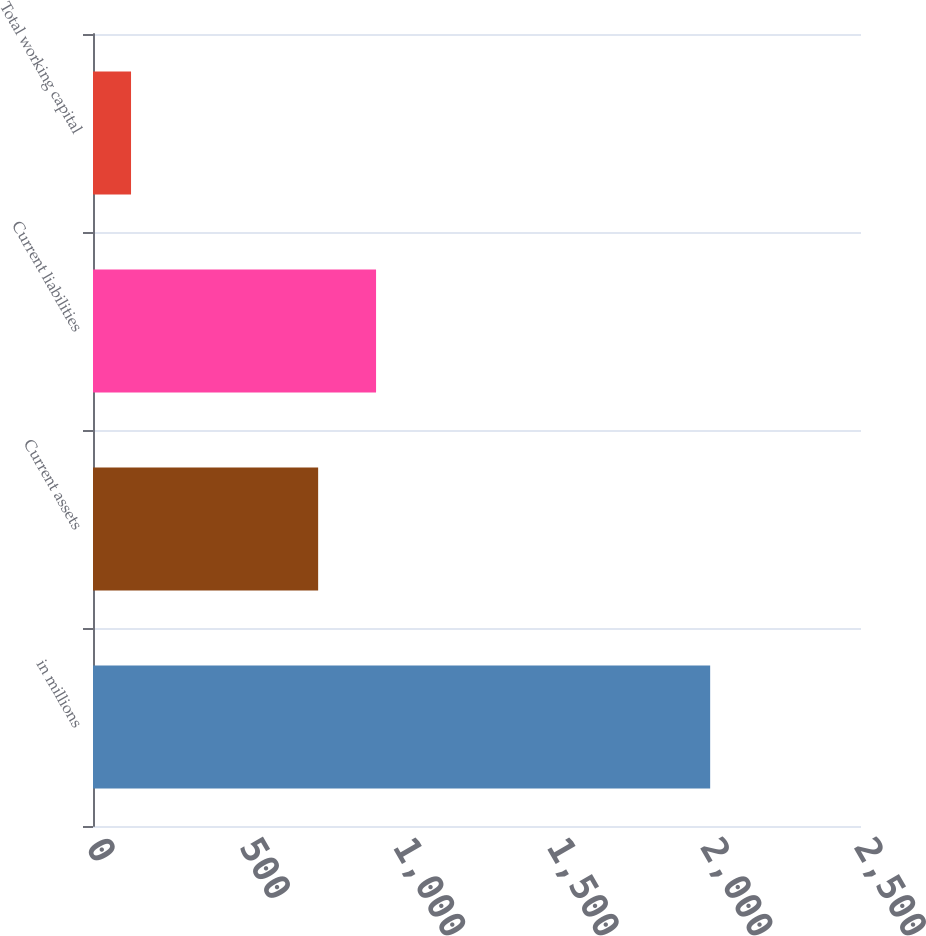Convert chart to OTSL. <chart><loc_0><loc_0><loc_500><loc_500><bar_chart><fcel>in millions<fcel>Current assets<fcel>Current liabilities<fcel>Total working capital<nl><fcel>2009<fcel>732.9<fcel>921.42<fcel>123.8<nl></chart> 